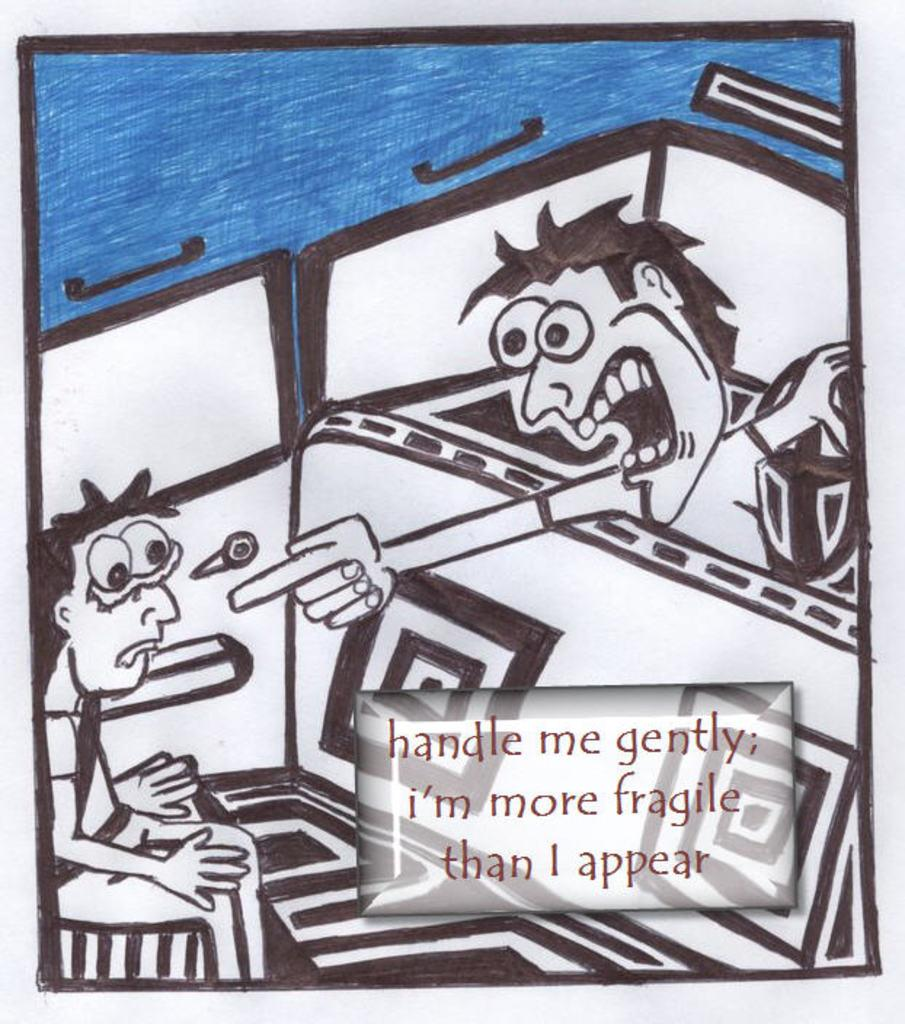<image>
Give a short and clear explanation of the subsequent image. A cartoon of a man pointing at another man and telling him that he is fragile. 